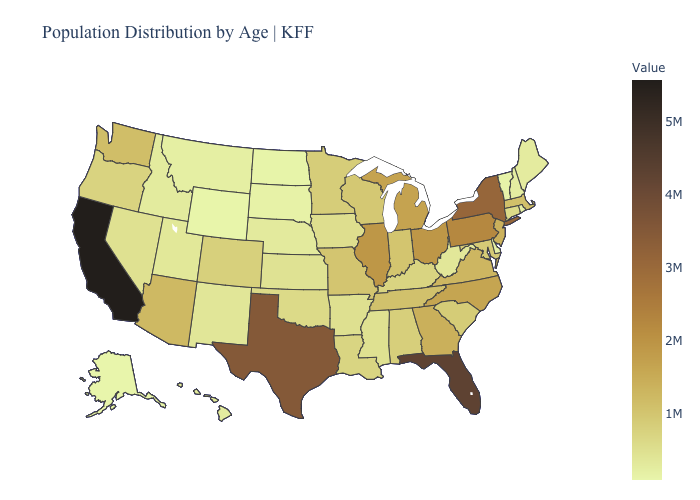Among the states that border Wyoming , which have the highest value?
Short answer required. Colorado. Does South Carolina have a higher value than Michigan?
Short answer required. No. 